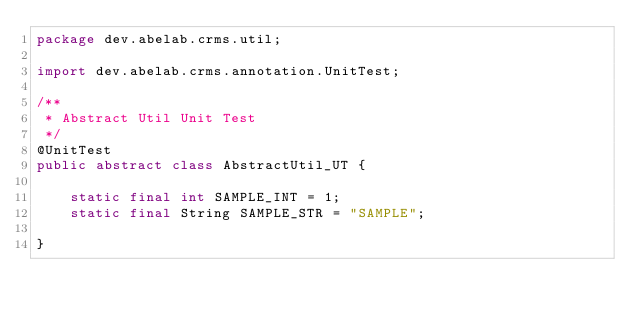Convert code to text. <code><loc_0><loc_0><loc_500><loc_500><_Java_>package dev.abelab.crms.util;

import dev.abelab.crms.annotation.UnitTest;

/**
 * Abstract Util Unit Test
 */
@UnitTest
public abstract class AbstractUtil_UT {

    static final int SAMPLE_INT = 1;
    static final String SAMPLE_STR = "SAMPLE";

}
</code> 